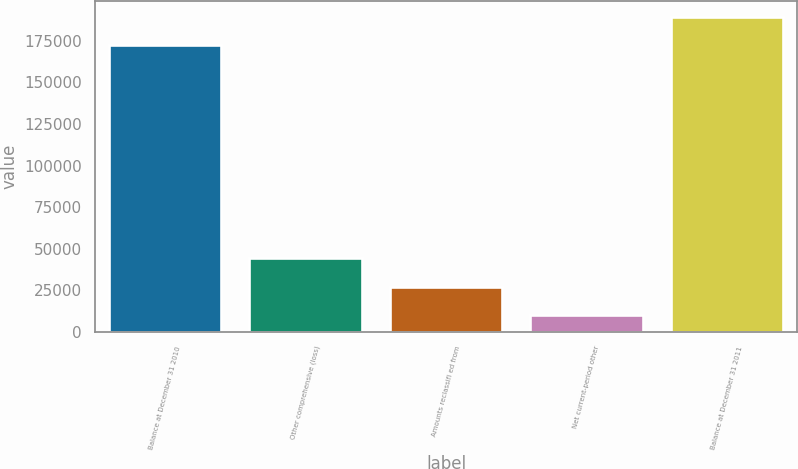<chart> <loc_0><loc_0><loc_500><loc_500><bar_chart><fcel>Balance at December 31 2010<fcel>Other comprehensive (loss)<fcel>Amounts reclassifi ed from<fcel>Net current-period other<fcel>Balance at December 31 2011<nl><fcel>172396<fcel>44585.2<fcel>27345.6<fcel>10106<fcel>189636<nl></chart> 